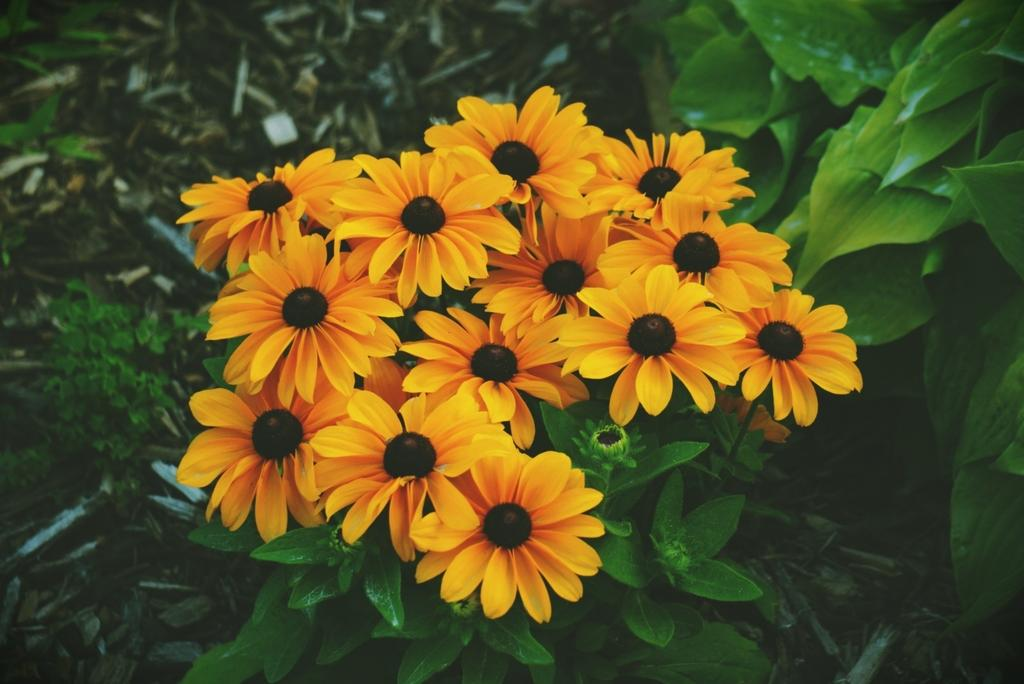What type of plants are in the image? There are flowers in the image. What colors are the flowers? The flowers are in yellow and black colors. What else can be seen in the image besides the flowers? There are green leaves in the image. How far away is the carpenter from the flowers in the image? There is no carpenter present in the image, so it is not possible to determine the distance between the carpenter and the flowers. 